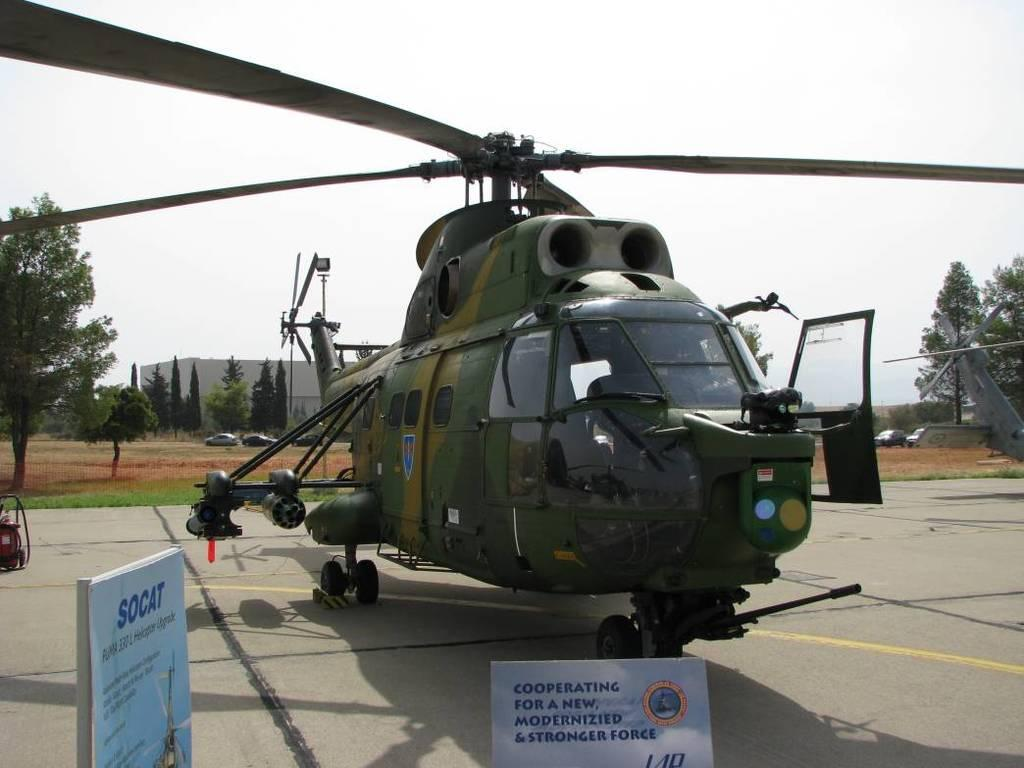<image>
Give a short and clear explanation of the subsequent image. Cooperating for a new modernized and stronger force is displayed on a sign in front of this helicopter. 